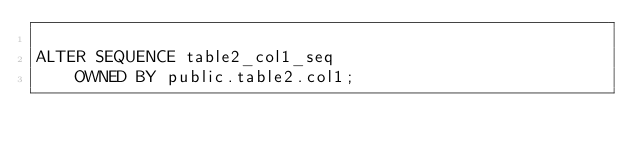<code> <loc_0><loc_0><loc_500><loc_500><_SQL_>
ALTER SEQUENCE table2_col1_seq
	OWNED BY public.table2.col1;
</code> 